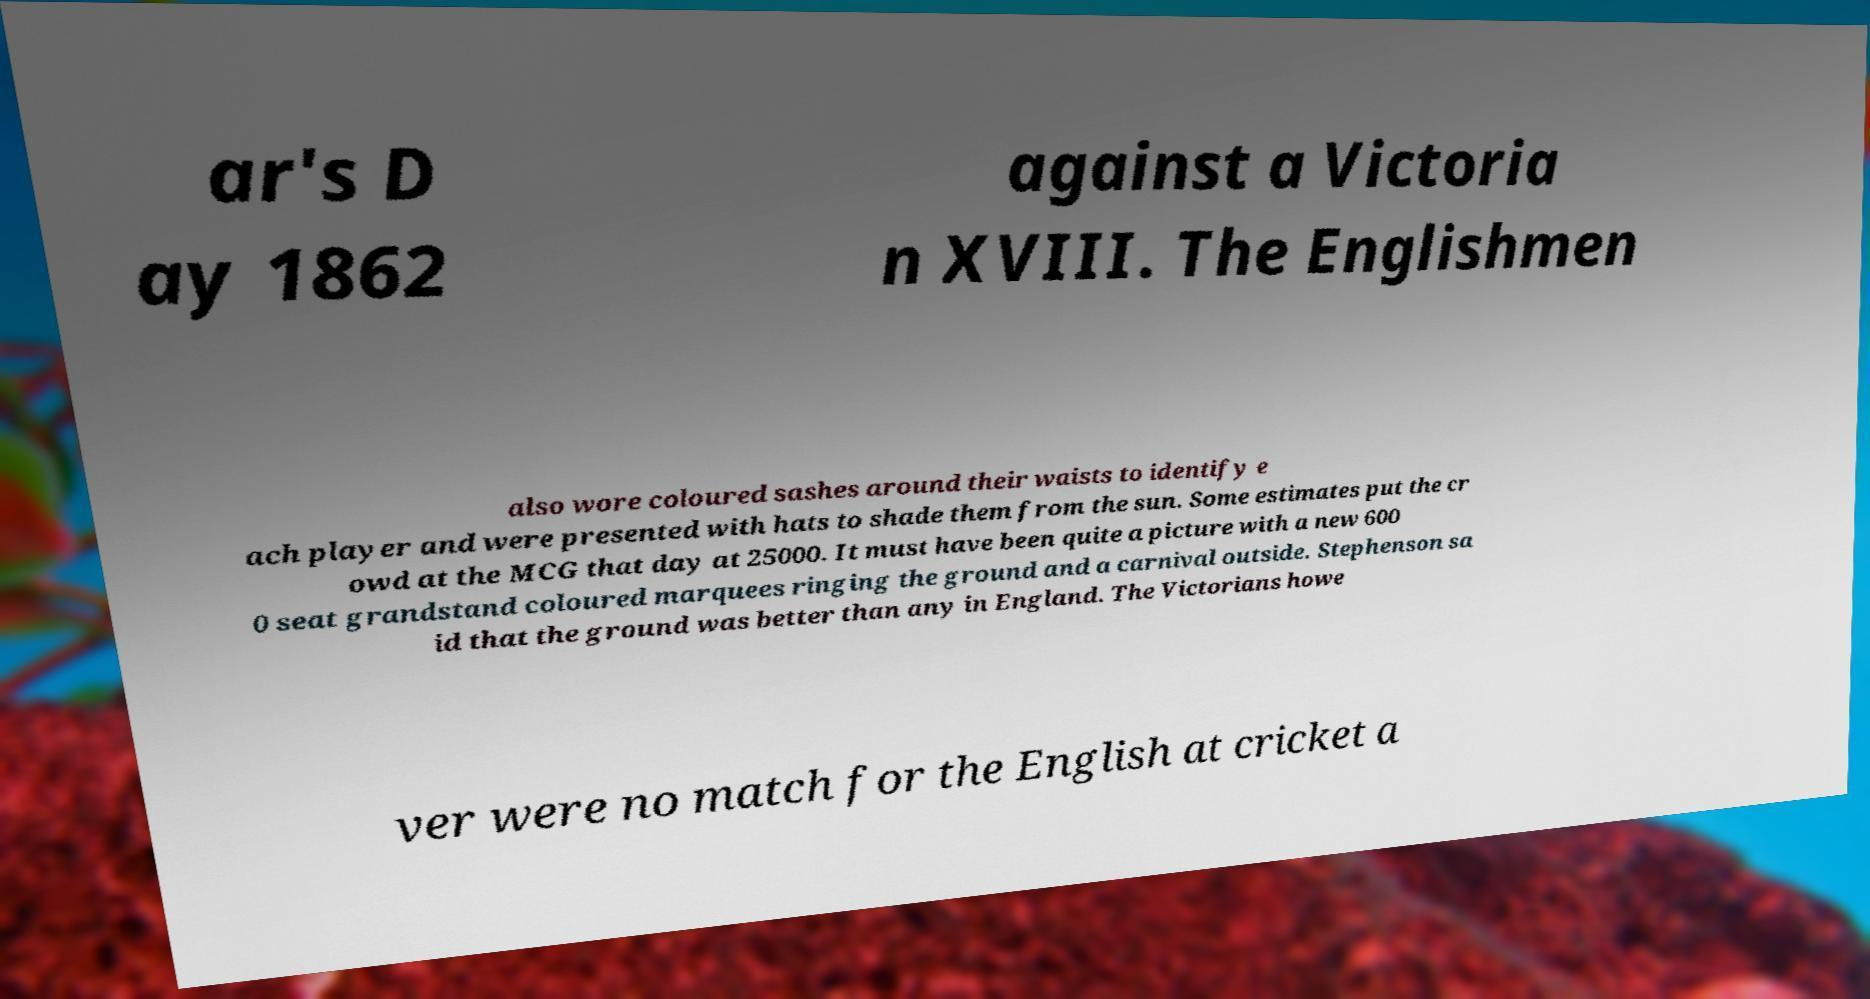Could you assist in decoding the text presented in this image and type it out clearly? ar's D ay 1862 against a Victoria n XVIII. The Englishmen also wore coloured sashes around their waists to identify e ach player and were presented with hats to shade them from the sun. Some estimates put the cr owd at the MCG that day at 25000. It must have been quite a picture with a new 600 0 seat grandstand coloured marquees ringing the ground and a carnival outside. Stephenson sa id that the ground was better than any in England. The Victorians howe ver were no match for the English at cricket a 